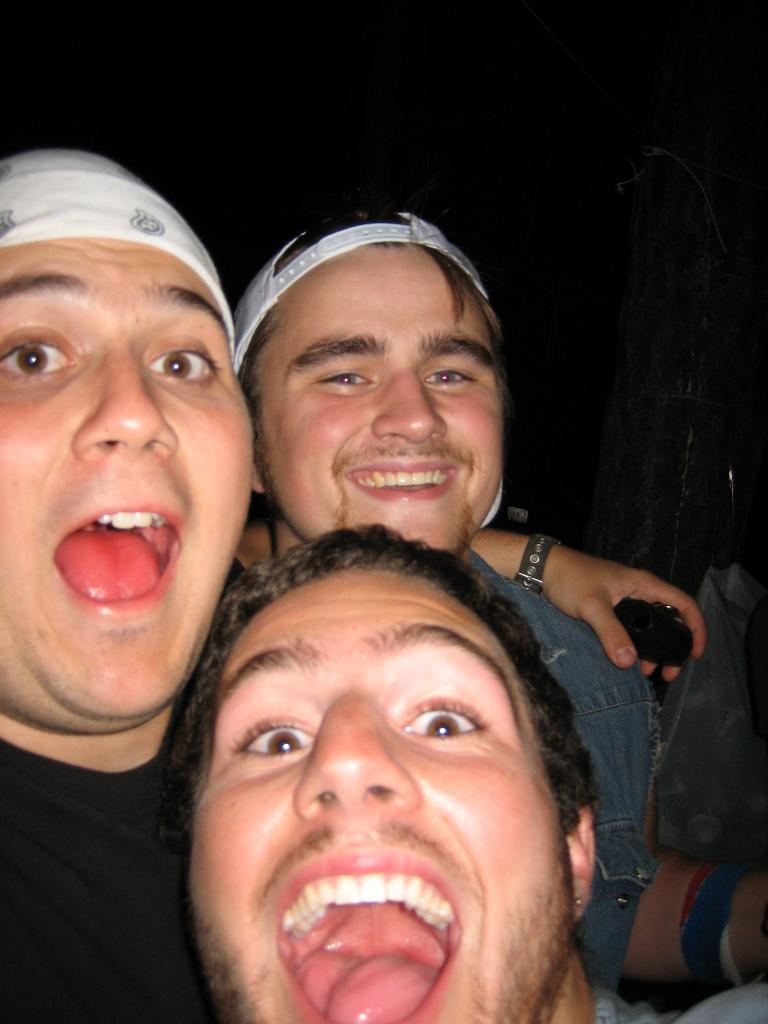What is the person in the image wearing on their upper body? The person is wearing a black t-shirt in the image. What type of headwear is the person wearing? The person is wearing a white cap. How many other people are present in the image? There are two other persons in the image. What color is the background of the image? The background of the image is black. What type of stove can be seen in the background of the image? There is no stove present in the image; the background is black. What experience does the person in the image have with cooking on a branch? There is no mention of cooking or a branch in the image, so it is impossible to determine any experience related to that. 